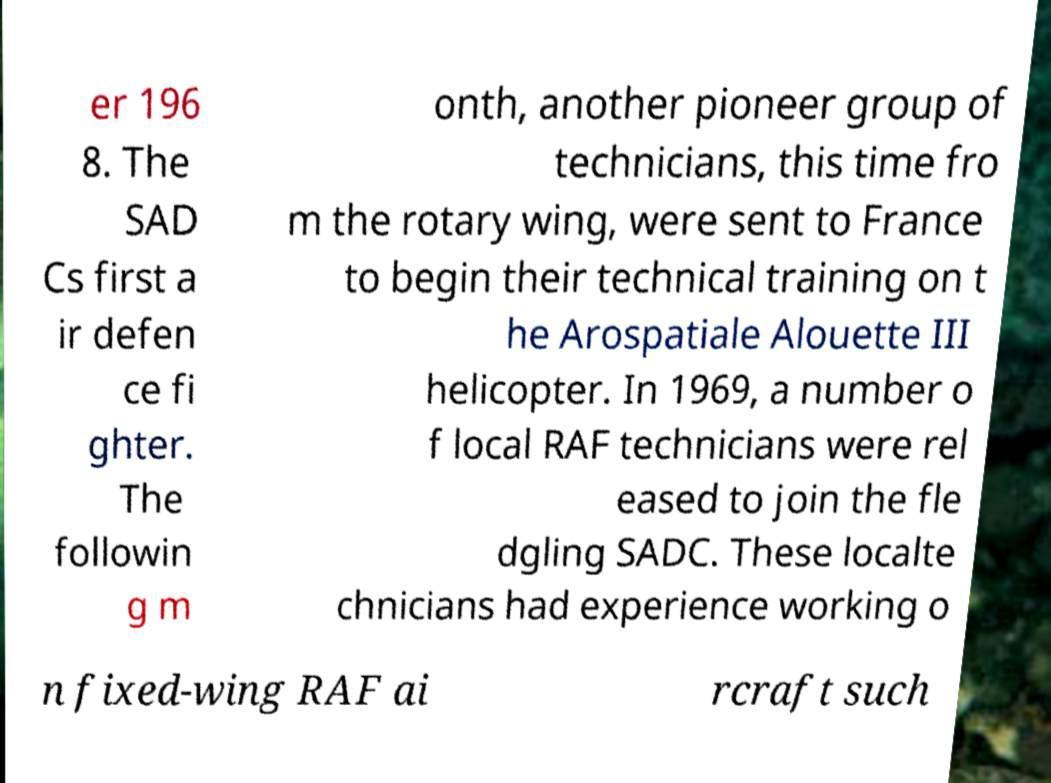What messages or text are displayed in this image? I need them in a readable, typed format. er 196 8. The SAD Cs first a ir defen ce fi ghter. The followin g m onth, another pioneer group of technicians, this time fro m the rotary wing, were sent to France to begin their technical training on t he Arospatiale Alouette III helicopter. In 1969, a number o f local RAF technicians were rel eased to join the fle dgling SADC. These localte chnicians had experience working o n fixed-wing RAF ai rcraft such 